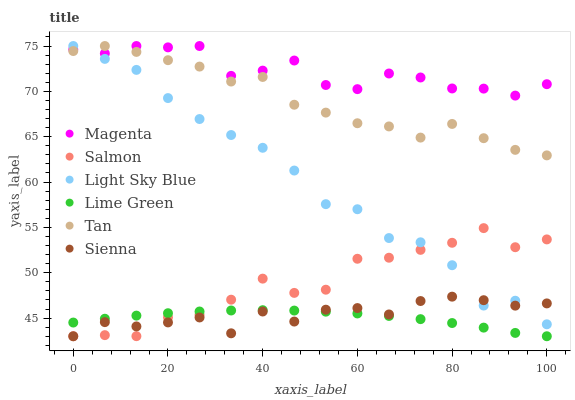Does Lime Green have the minimum area under the curve?
Answer yes or no. Yes. Does Magenta have the maximum area under the curve?
Answer yes or no. Yes. Does Sienna have the minimum area under the curve?
Answer yes or no. No. Does Sienna have the maximum area under the curve?
Answer yes or no. No. Is Lime Green the smoothest?
Answer yes or no. Yes. Is Salmon the roughest?
Answer yes or no. Yes. Is Sienna the smoothest?
Answer yes or no. No. Is Sienna the roughest?
Answer yes or no. No. Does Salmon have the lowest value?
Answer yes or no. Yes. Does Light Sky Blue have the lowest value?
Answer yes or no. No. Does Tan have the highest value?
Answer yes or no. Yes. Does Sienna have the highest value?
Answer yes or no. No. Is Lime Green less than Magenta?
Answer yes or no. Yes. Is Tan greater than Lime Green?
Answer yes or no. Yes. Does Lime Green intersect Sienna?
Answer yes or no. Yes. Is Lime Green less than Sienna?
Answer yes or no. No. Is Lime Green greater than Sienna?
Answer yes or no. No. Does Lime Green intersect Magenta?
Answer yes or no. No. 